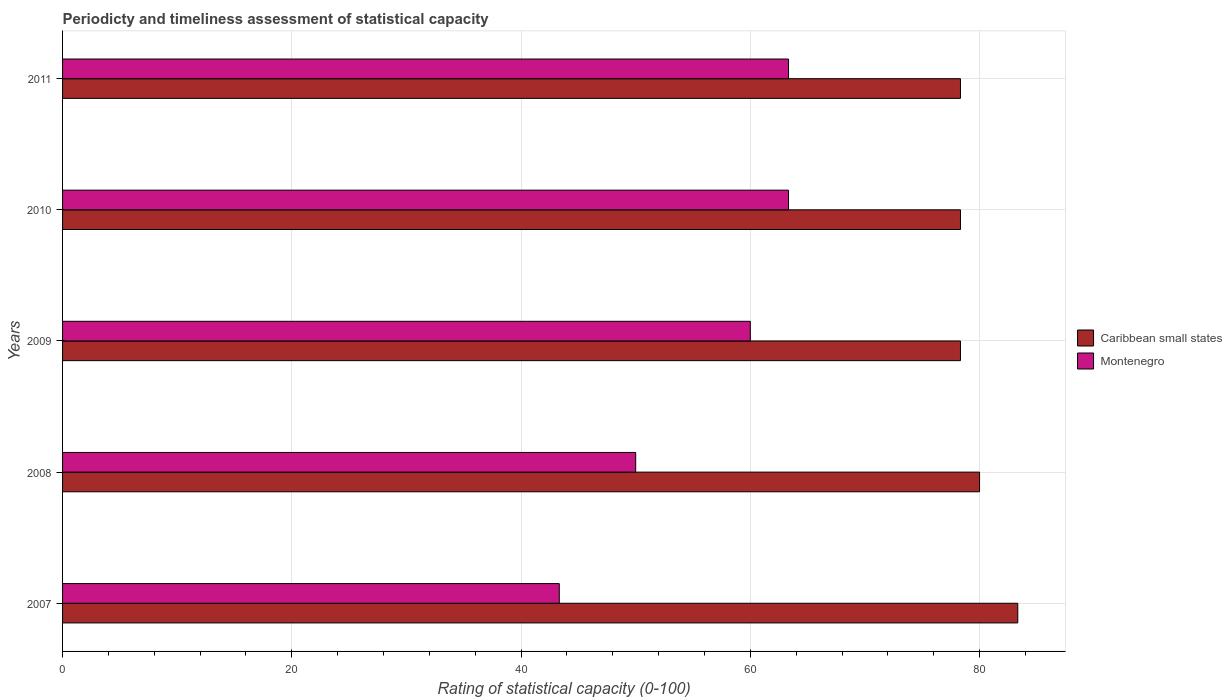How many different coloured bars are there?
Provide a short and direct response. 2. Are the number of bars per tick equal to the number of legend labels?
Provide a succinct answer. Yes. Are the number of bars on each tick of the Y-axis equal?
Provide a succinct answer. Yes. How many bars are there on the 2nd tick from the top?
Your response must be concise. 2. How many bars are there on the 2nd tick from the bottom?
Make the answer very short. 2. What is the label of the 1st group of bars from the top?
Keep it short and to the point. 2011. What is the rating of statistical capacity in Caribbean small states in 2007?
Your answer should be very brief. 83.33. Across all years, what is the maximum rating of statistical capacity in Montenegro?
Make the answer very short. 63.33. Across all years, what is the minimum rating of statistical capacity in Caribbean small states?
Offer a terse response. 78.33. In which year was the rating of statistical capacity in Montenegro maximum?
Your response must be concise. 2010. What is the total rating of statistical capacity in Caribbean small states in the graph?
Provide a succinct answer. 398.33. What is the difference between the rating of statistical capacity in Caribbean small states in 2007 and that in 2011?
Your response must be concise. 5. What is the difference between the rating of statistical capacity in Caribbean small states in 2010 and the rating of statistical capacity in Montenegro in 2007?
Offer a very short reply. 35. What is the average rating of statistical capacity in Montenegro per year?
Make the answer very short. 56. In the year 2011, what is the difference between the rating of statistical capacity in Montenegro and rating of statistical capacity in Caribbean small states?
Make the answer very short. -15. What is the ratio of the rating of statistical capacity in Caribbean small states in 2007 to that in 2011?
Your response must be concise. 1.06. Is the difference between the rating of statistical capacity in Montenegro in 2009 and 2010 greater than the difference between the rating of statistical capacity in Caribbean small states in 2009 and 2010?
Give a very brief answer. No. What is the difference between the highest and the second highest rating of statistical capacity in Caribbean small states?
Ensure brevity in your answer.  3.33. What is the difference between the highest and the lowest rating of statistical capacity in Caribbean small states?
Your response must be concise. 5. In how many years, is the rating of statistical capacity in Montenegro greater than the average rating of statistical capacity in Montenegro taken over all years?
Make the answer very short. 3. What does the 1st bar from the top in 2008 represents?
Provide a short and direct response. Montenegro. What does the 2nd bar from the bottom in 2007 represents?
Ensure brevity in your answer.  Montenegro. How many bars are there?
Give a very brief answer. 10. What is the difference between two consecutive major ticks on the X-axis?
Give a very brief answer. 20. Are the values on the major ticks of X-axis written in scientific E-notation?
Keep it short and to the point. No. Does the graph contain any zero values?
Offer a very short reply. No. Does the graph contain grids?
Offer a terse response. Yes. What is the title of the graph?
Offer a terse response. Periodicty and timeliness assessment of statistical capacity. Does "Latin America(all income levels)" appear as one of the legend labels in the graph?
Your response must be concise. No. What is the label or title of the X-axis?
Offer a terse response. Rating of statistical capacity (0-100). What is the label or title of the Y-axis?
Your answer should be very brief. Years. What is the Rating of statistical capacity (0-100) of Caribbean small states in 2007?
Give a very brief answer. 83.33. What is the Rating of statistical capacity (0-100) in Montenegro in 2007?
Provide a succinct answer. 43.33. What is the Rating of statistical capacity (0-100) of Montenegro in 2008?
Provide a succinct answer. 50. What is the Rating of statistical capacity (0-100) in Caribbean small states in 2009?
Provide a short and direct response. 78.33. What is the Rating of statistical capacity (0-100) in Montenegro in 2009?
Keep it short and to the point. 60. What is the Rating of statistical capacity (0-100) of Caribbean small states in 2010?
Keep it short and to the point. 78.33. What is the Rating of statistical capacity (0-100) in Montenegro in 2010?
Give a very brief answer. 63.33. What is the Rating of statistical capacity (0-100) of Caribbean small states in 2011?
Ensure brevity in your answer.  78.33. What is the Rating of statistical capacity (0-100) in Montenegro in 2011?
Provide a short and direct response. 63.33. Across all years, what is the maximum Rating of statistical capacity (0-100) of Caribbean small states?
Provide a short and direct response. 83.33. Across all years, what is the maximum Rating of statistical capacity (0-100) in Montenegro?
Keep it short and to the point. 63.33. Across all years, what is the minimum Rating of statistical capacity (0-100) of Caribbean small states?
Make the answer very short. 78.33. Across all years, what is the minimum Rating of statistical capacity (0-100) in Montenegro?
Offer a terse response. 43.33. What is the total Rating of statistical capacity (0-100) in Caribbean small states in the graph?
Offer a very short reply. 398.33. What is the total Rating of statistical capacity (0-100) of Montenegro in the graph?
Ensure brevity in your answer.  280. What is the difference between the Rating of statistical capacity (0-100) in Caribbean small states in 2007 and that in 2008?
Offer a terse response. 3.33. What is the difference between the Rating of statistical capacity (0-100) in Montenegro in 2007 and that in 2008?
Provide a succinct answer. -6.67. What is the difference between the Rating of statistical capacity (0-100) in Montenegro in 2007 and that in 2009?
Make the answer very short. -16.67. What is the difference between the Rating of statistical capacity (0-100) in Caribbean small states in 2007 and that in 2010?
Keep it short and to the point. 5. What is the difference between the Rating of statistical capacity (0-100) of Montenegro in 2007 and that in 2010?
Offer a terse response. -20. What is the difference between the Rating of statistical capacity (0-100) of Caribbean small states in 2008 and that in 2009?
Make the answer very short. 1.67. What is the difference between the Rating of statistical capacity (0-100) of Montenegro in 2008 and that in 2009?
Offer a very short reply. -10. What is the difference between the Rating of statistical capacity (0-100) of Montenegro in 2008 and that in 2010?
Keep it short and to the point. -13.33. What is the difference between the Rating of statistical capacity (0-100) of Montenegro in 2008 and that in 2011?
Ensure brevity in your answer.  -13.33. What is the difference between the Rating of statistical capacity (0-100) of Caribbean small states in 2009 and that in 2011?
Your answer should be compact. 0. What is the difference between the Rating of statistical capacity (0-100) in Montenegro in 2009 and that in 2011?
Make the answer very short. -3.33. What is the difference between the Rating of statistical capacity (0-100) in Caribbean small states in 2007 and the Rating of statistical capacity (0-100) in Montenegro in 2008?
Offer a very short reply. 33.33. What is the difference between the Rating of statistical capacity (0-100) in Caribbean small states in 2007 and the Rating of statistical capacity (0-100) in Montenegro in 2009?
Make the answer very short. 23.33. What is the difference between the Rating of statistical capacity (0-100) of Caribbean small states in 2007 and the Rating of statistical capacity (0-100) of Montenegro in 2010?
Your response must be concise. 20. What is the difference between the Rating of statistical capacity (0-100) of Caribbean small states in 2007 and the Rating of statistical capacity (0-100) of Montenegro in 2011?
Ensure brevity in your answer.  20. What is the difference between the Rating of statistical capacity (0-100) in Caribbean small states in 2008 and the Rating of statistical capacity (0-100) in Montenegro in 2010?
Provide a short and direct response. 16.67. What is the difference between the Rating of statistical capacity (0-100) of Caribbean small states in 2008 and the Rating of statistical capacity (0-100) of Montenegro in 2011?
Ensure brevity in your answer.  16.67. What is the difference between the Rating of statistical capacity (0-100) of Caribbean small states in 2009 and the Rating of statistical capacity (0-100) of Montenegro in 2011?
Your answer should be very brief. 15. What is the difference between the Rating of statistical capacity (0-100) in Caribbean small states in 2010 and the Rating of statistical capacity (0-100) in Montenegro in 2011?
Provide a short and direct response. 15. What is the average Rating of statistical capacity (0-100) of Caribbean small states per year?
Ensure brevity in your answer.  79.67. What is the average Rating of statistical capacity (0-100) of Montenegro per year?
Offer a terse response. 56. In the year 2007, what is the difference between the Rating of statistical capacity (0-100) in Caribbean small states and Rating of statistical capacity (0-100) in Montenegro?
Offer a terse response. 40. In the year 2009, what is the difference between the Rating of statistical capacity (0-100) in Caribbean small states and Rating of statistical capacity (0-100) in Montenegro?
Give a very brief answer. 18.33. In the year 2010, what is the difference between the Rating of statistical capacity (0-100) in Caribbean small states and Rating of statistical capacity (0-100) in Montenegro?
Keep it short and to the point. 15. What is the ratio of the Rating of statistical capacity (0-100) of Caribbean small states in 2007 to that in 2008?
Give a very brief answer. 1.04. What is the ratio of the Rating of statistical capacity (0-100) in Montenegro in 2007 to that in 2008?
Offer a very short reply. 0.87. What is the ratio of the Rating of statistical capacity (0-100) of Caribbean small states in 2007 to that in 2009?
Provide a short and direct response. 1.06. What is the ratio of the Rating of statistical capacity (0-100) in Montenegro in 2007 to that in 2009?
Your answer should be very brief. 0.72. What is the ratio of the Rating of statistical capacity (0-100) of Caribbean small states in 2007 to that in 2010?
Your response must be concise. 1.06. What is the ratio of the Rating of statistical capacity (0-100) of Montenegro in 2007 to that in 2010?
Provide a succinct answer. 0.68. What is the ratio of the Rating of statistical capacity (0-100) of Caribbean small states in 2007 to that in 2011?
Offer a very short reply. 1.06. What is the ratio of the Rating of statistical capacity (0-100) in Montenegro in 2007 to that in 2011?
Keep it short and to the point. 0.68. What is the ratio of the Rating of statistical capacity (0-100) of Caribbean small states in 2008 to that in 2009?
Your response must be concise. 1.02. What is the ratio of the Rating of statistical capacity (0-100) in Caribbean small states in 2008 to that in 2010?
Give a very brief answer. 1.02. What is the ratio of the Rating of statistical capacity (0-100) of Montenegro in 2008 to that in 2010?
Your answer should be compact. 0.79. What is the ratio of the Rating of statistical capacity (0-100) of Caribbean small states in 2008 to that in 2011?
Provide a short and direct response. 1.02. What is the ratio of the Rating of statistical capacity (0-100) in Montenegro in 2008 to that in 2011?
Your answer should be very brief. 0.79. What is the ratio of the Rating of statistical capacity (0-100) in Caribbean small states in 2009 to that in 2010?
Keep it short and to the point. 1. What is the ratio of the Rating of statistical capacity (0-100) of Caribbean small states in 2010 to that in 2011?
Provide a succinct answer. 1. What is the difference between the highest and the lowest Rating of statistical capacity (0-100) of Caribbean small states?
Provide a succinct answer. 5. What is the difference between the highest and the lowest Rating of statistical capacity (0-100) of Montenegro?
Your answer should be very brief. 20. 